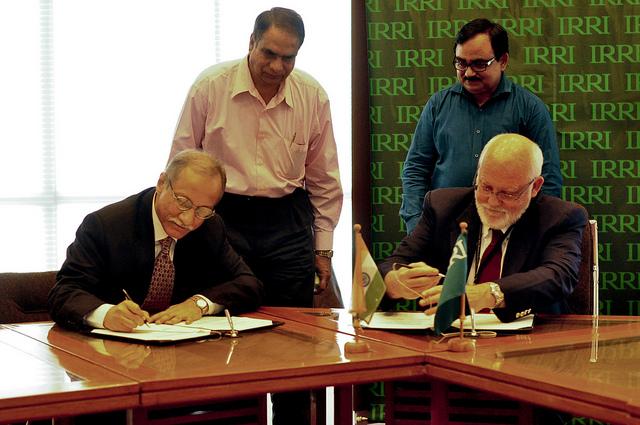What is the name on the wall?
Keep it brief. Irri. How many men are wearing  glasses?
Keep it brief. 3. How many men are sitting down?
Answer briefly. 2. 